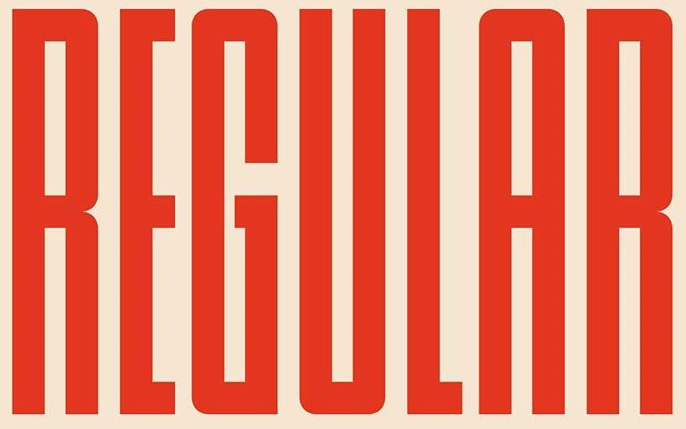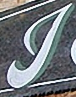What text is displayed in these images sequentially, separated by a semicolon? REGULAR; J 